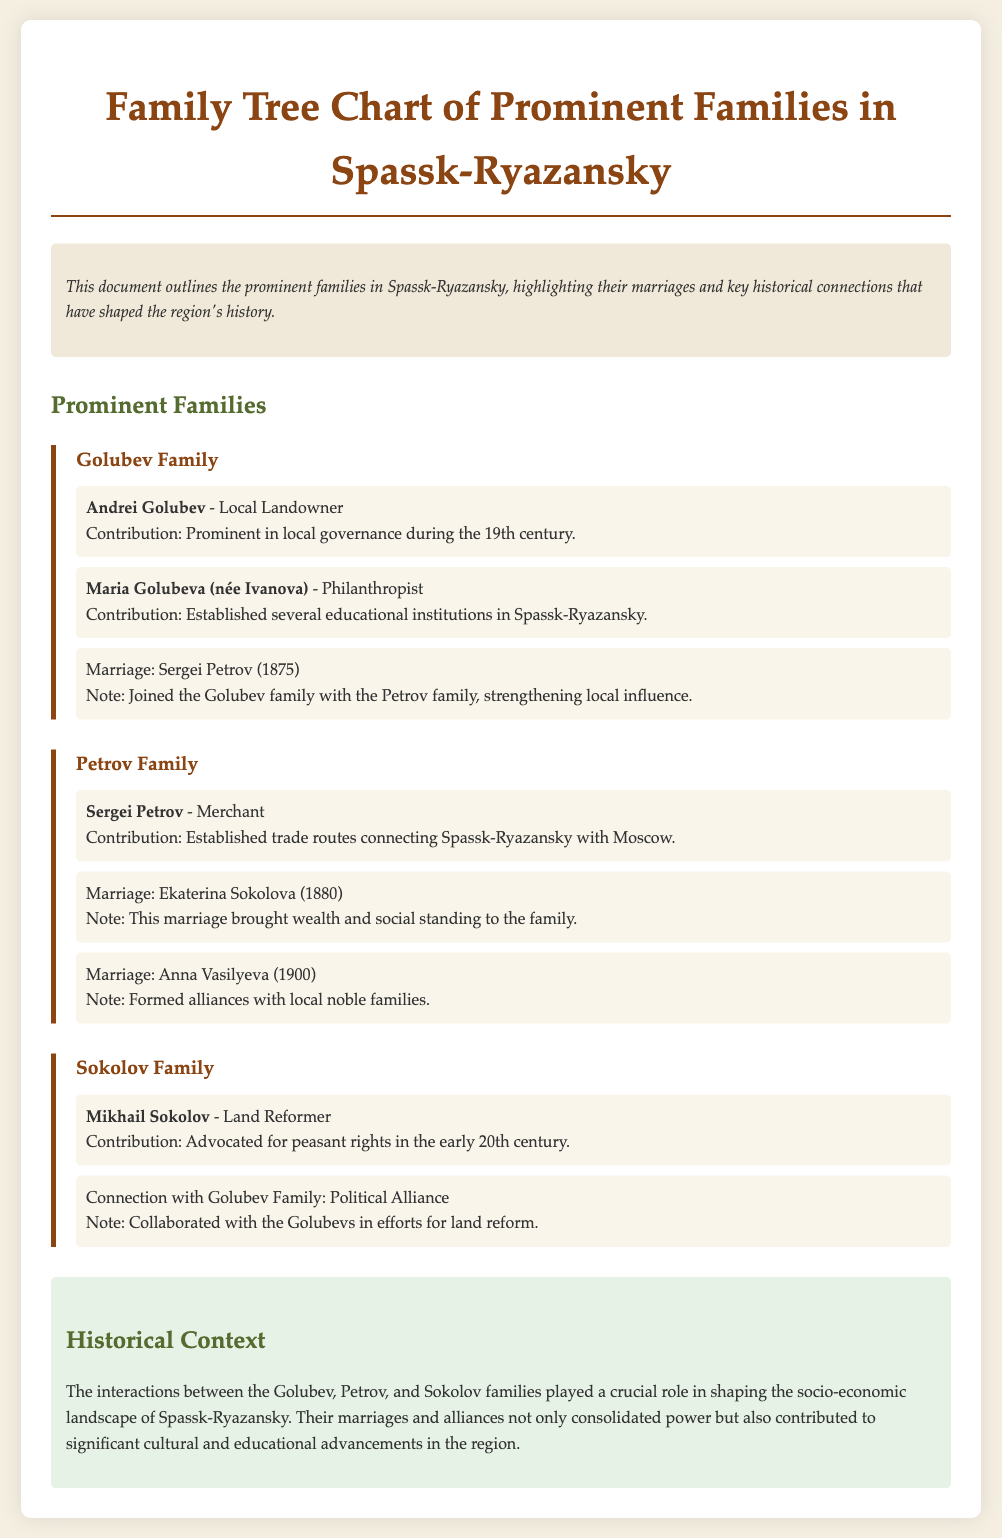What is the main purpose of the document? The document outlines the prominent families in Spassk-Ryazansky, highlighting their marriages and key historical connections that have shaped the region's history.
Answer: To outline prominent families and their connections Who was a prominent landowner in the Golubev family? Andrei Golubev is identified as a local landowner in the Golubev family section.
Answer: Andrei Golubev What year did Sergei Petrov marry into the Golubev family? The marriage note states that Sergei Petrov joined the Golubev family in 1875.
Answer: 1875 Which family was connected with the Golubev family through a political alliance? The document mentions a political alliance with the Sokolov family.
Answer: Sokolov Family What contribution did Maria Golubeva make to Spassk-Ryazansky? She established several educational institutions in the region.
Answer: Established educational institutions In what century did Mikhail Sokolov advocate for peasant rights? The document states he advocated for peasant rights in the early 20th century.
Answer: 20th century What was the profession of Sergei Petrov? The document categorizes Sergei Petrov as a merchant.
Answer: Merchant What type of advancements did the interactions among these families contribute to in Spassk-Ryazansky? The interactions contributed to significant cultural and educational advancements.
Answer: Cultural and educational advancements 